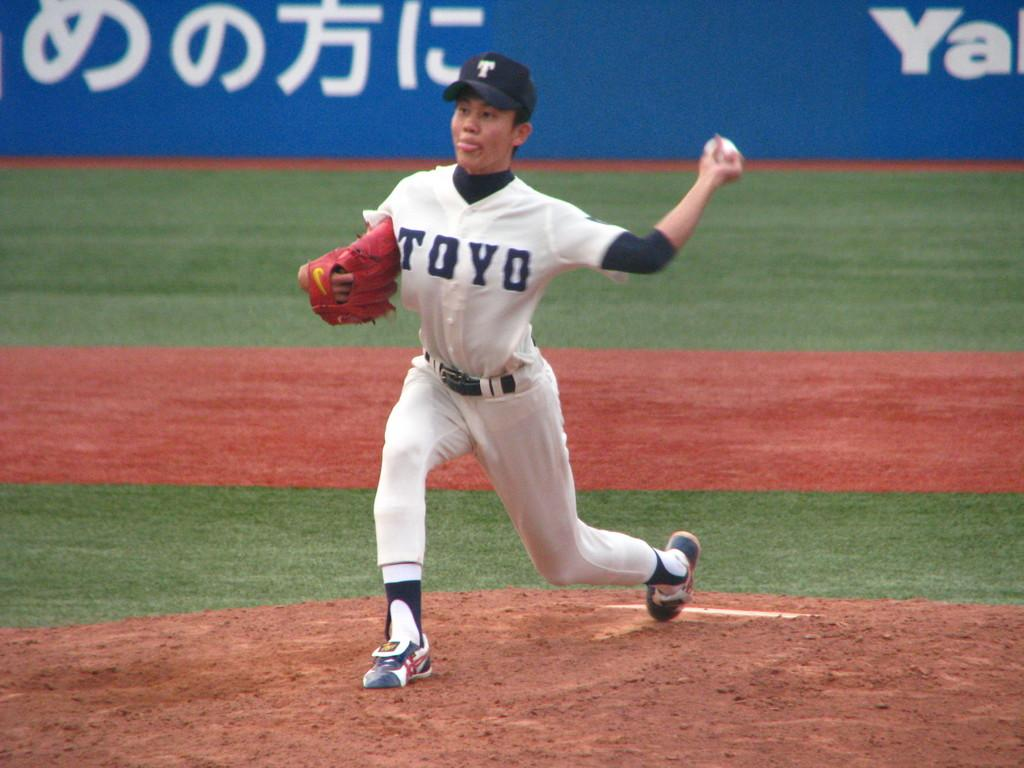Provide a one-sentence caption for the provided image. A person in a white top reading TOYO throwing a baseball. 